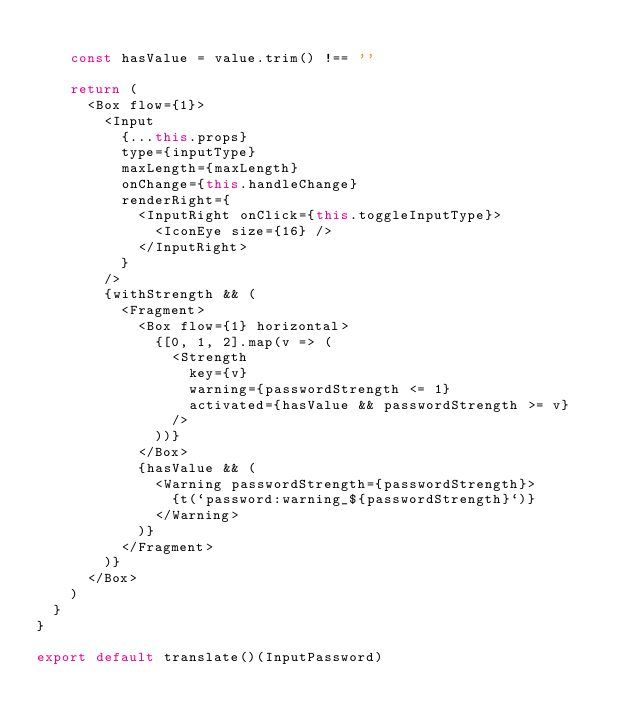Convert code to text. <code><loc_0><loc_0><loc_500><loc_500><_JavaScript_>
    const hasValue = value.trim() !== ''

    return (
      <Box flow={1}>
        <Input
          {...this.props}
          type={inputType}
          maxLength={maxLength}
          onChange={this.handleChange}
          renderRight={
            <InputRight onClick={this.toggleInputType}>
              <IconEye size={16} />
            </InputRight>
          }
        />
        {withStrength && (
          <Fragment>
            <Box flow={1} horizontal>
              {[0, 1, 2].map(v => (
                <Strength
                  key={v}
                  warning={passwordStrength <= 1}
                  activated={hasValue && passwordStrength >= v}
                />
              ))}
            </Box>
            {hasValue && (
              <Warning passwordStrength={passwordStrength}>
                {t(`password:warning_${passwordStrength}`)}
              </Warning>
            )}
          </Fragment>
        )}
      </Box>
    )
  }
}

export default translate()(InputPassword)
</code> 